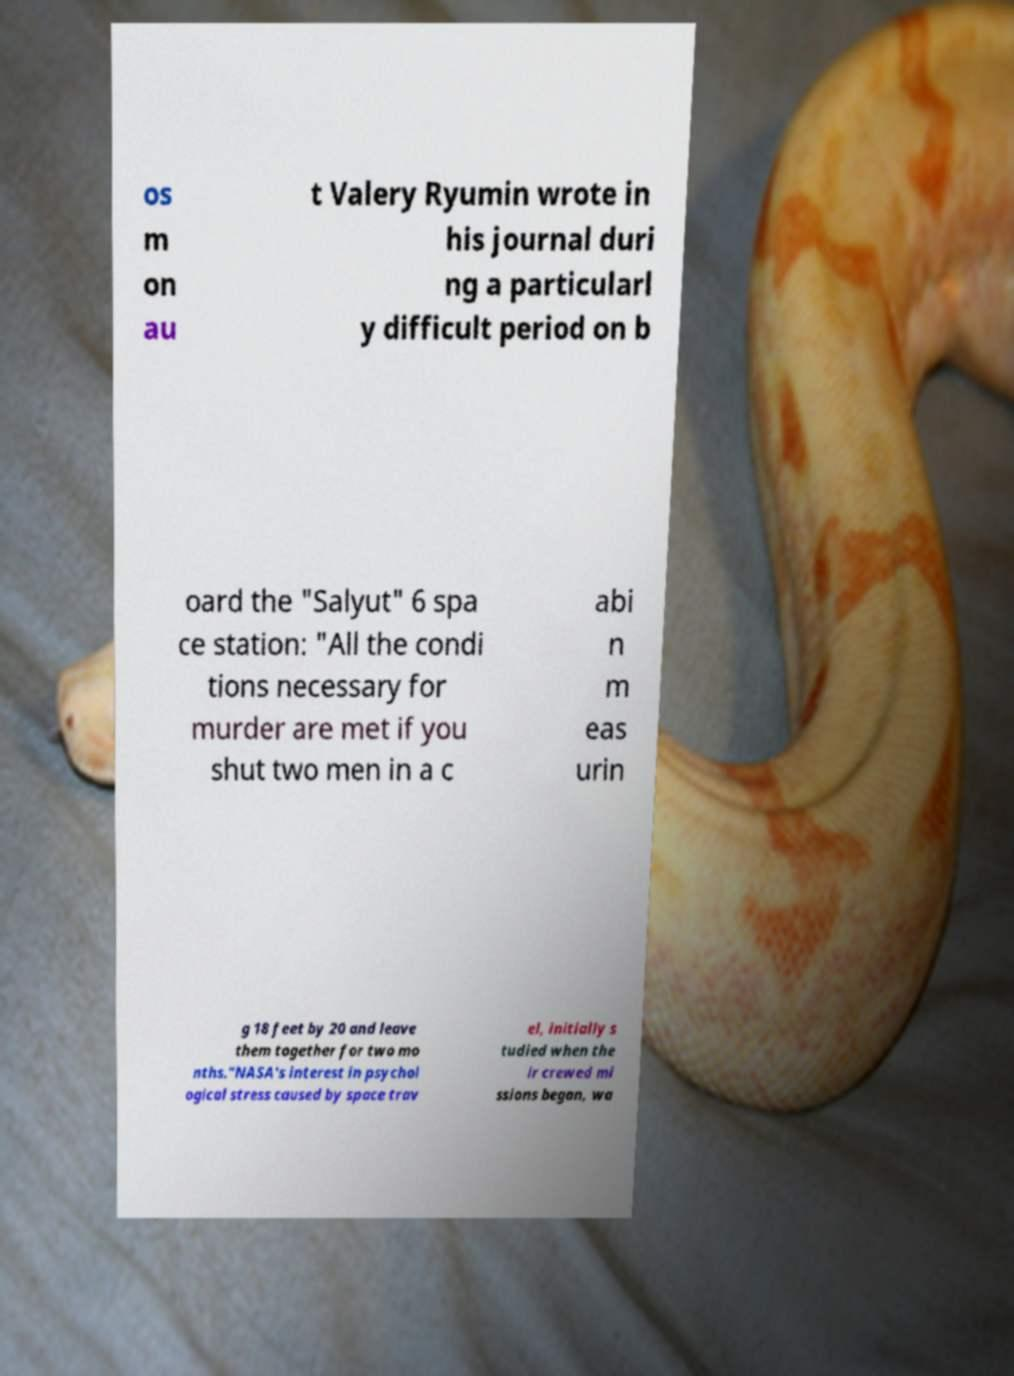Can you read and provide the text displayed in the image?This photo seems to have some interesting text. Can you extract and type it out for me? os m on au t Valery Ryumin wrote in his journal duri ng a particularl y difficult period on b oard the "Salyut" 6 spa ce station: "All the condi tions necessary for murder are met if you shut two men in a c abi n m eas urin g 18 feet by 20 and leave them together for two mo nths."NASA's interest in psychol ogical stress caused by space trav el, initially s tudied when the ir crewed mi ssions began, wa 